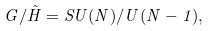Convert formula to latex. <formula><loc_0><loc_0><loc_500><loc_500>G / \tilde { H } = S U ( N ) / U ( N - 1 ) ,</formula> 